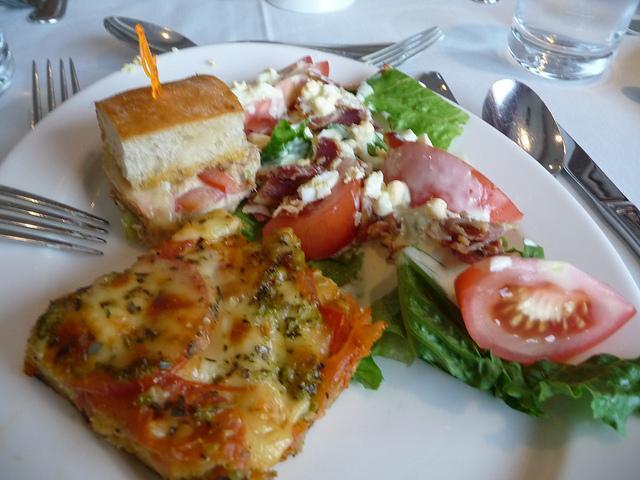How many cups are visible?
Give a very brief answer. 2. How many spoons are in the photo?
Give a very brief answer. 2. 